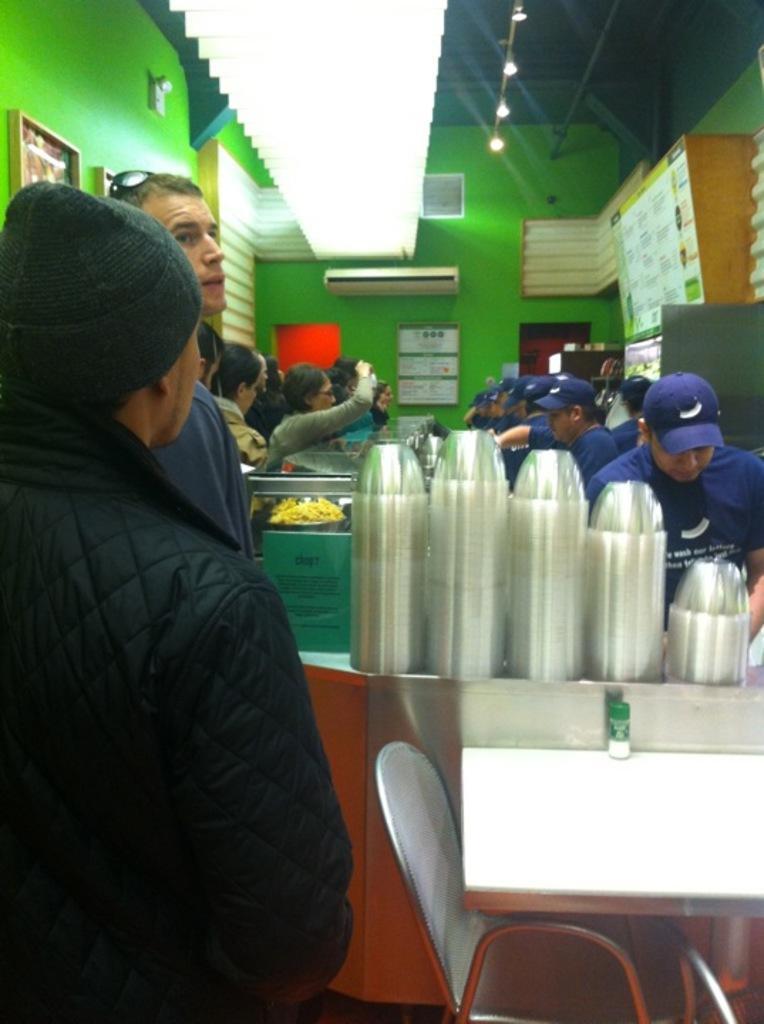Please provide a concise description of this image. In this picture we can see some persons. This is table. On the table there are cups. Here we can see a chair. On the background there is a wall and this is light. 